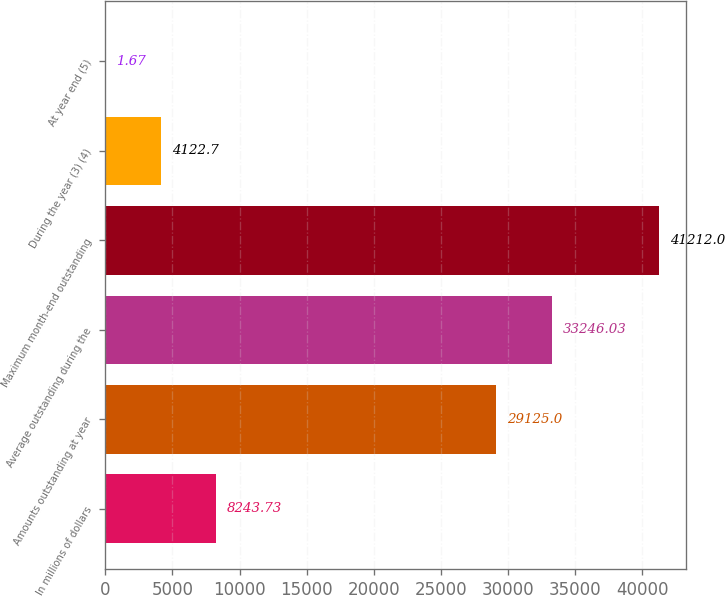Convert chart. <chart><loc_0><loc_0><loc_500><loc_500><bar_chart><fcel>In millions of dollars<fcel>Amounts outstanding at year<fcel>Average outstanding during the<fcel>Maximum month-end outstanding<fcel>During the year (3) (4)<fcel>At year end (5)<nl><fcel>8243.73<fcel>29125<fcel>33246<fcel>41212<fcel>4122.7<fcel>1.67<nl></chart> 